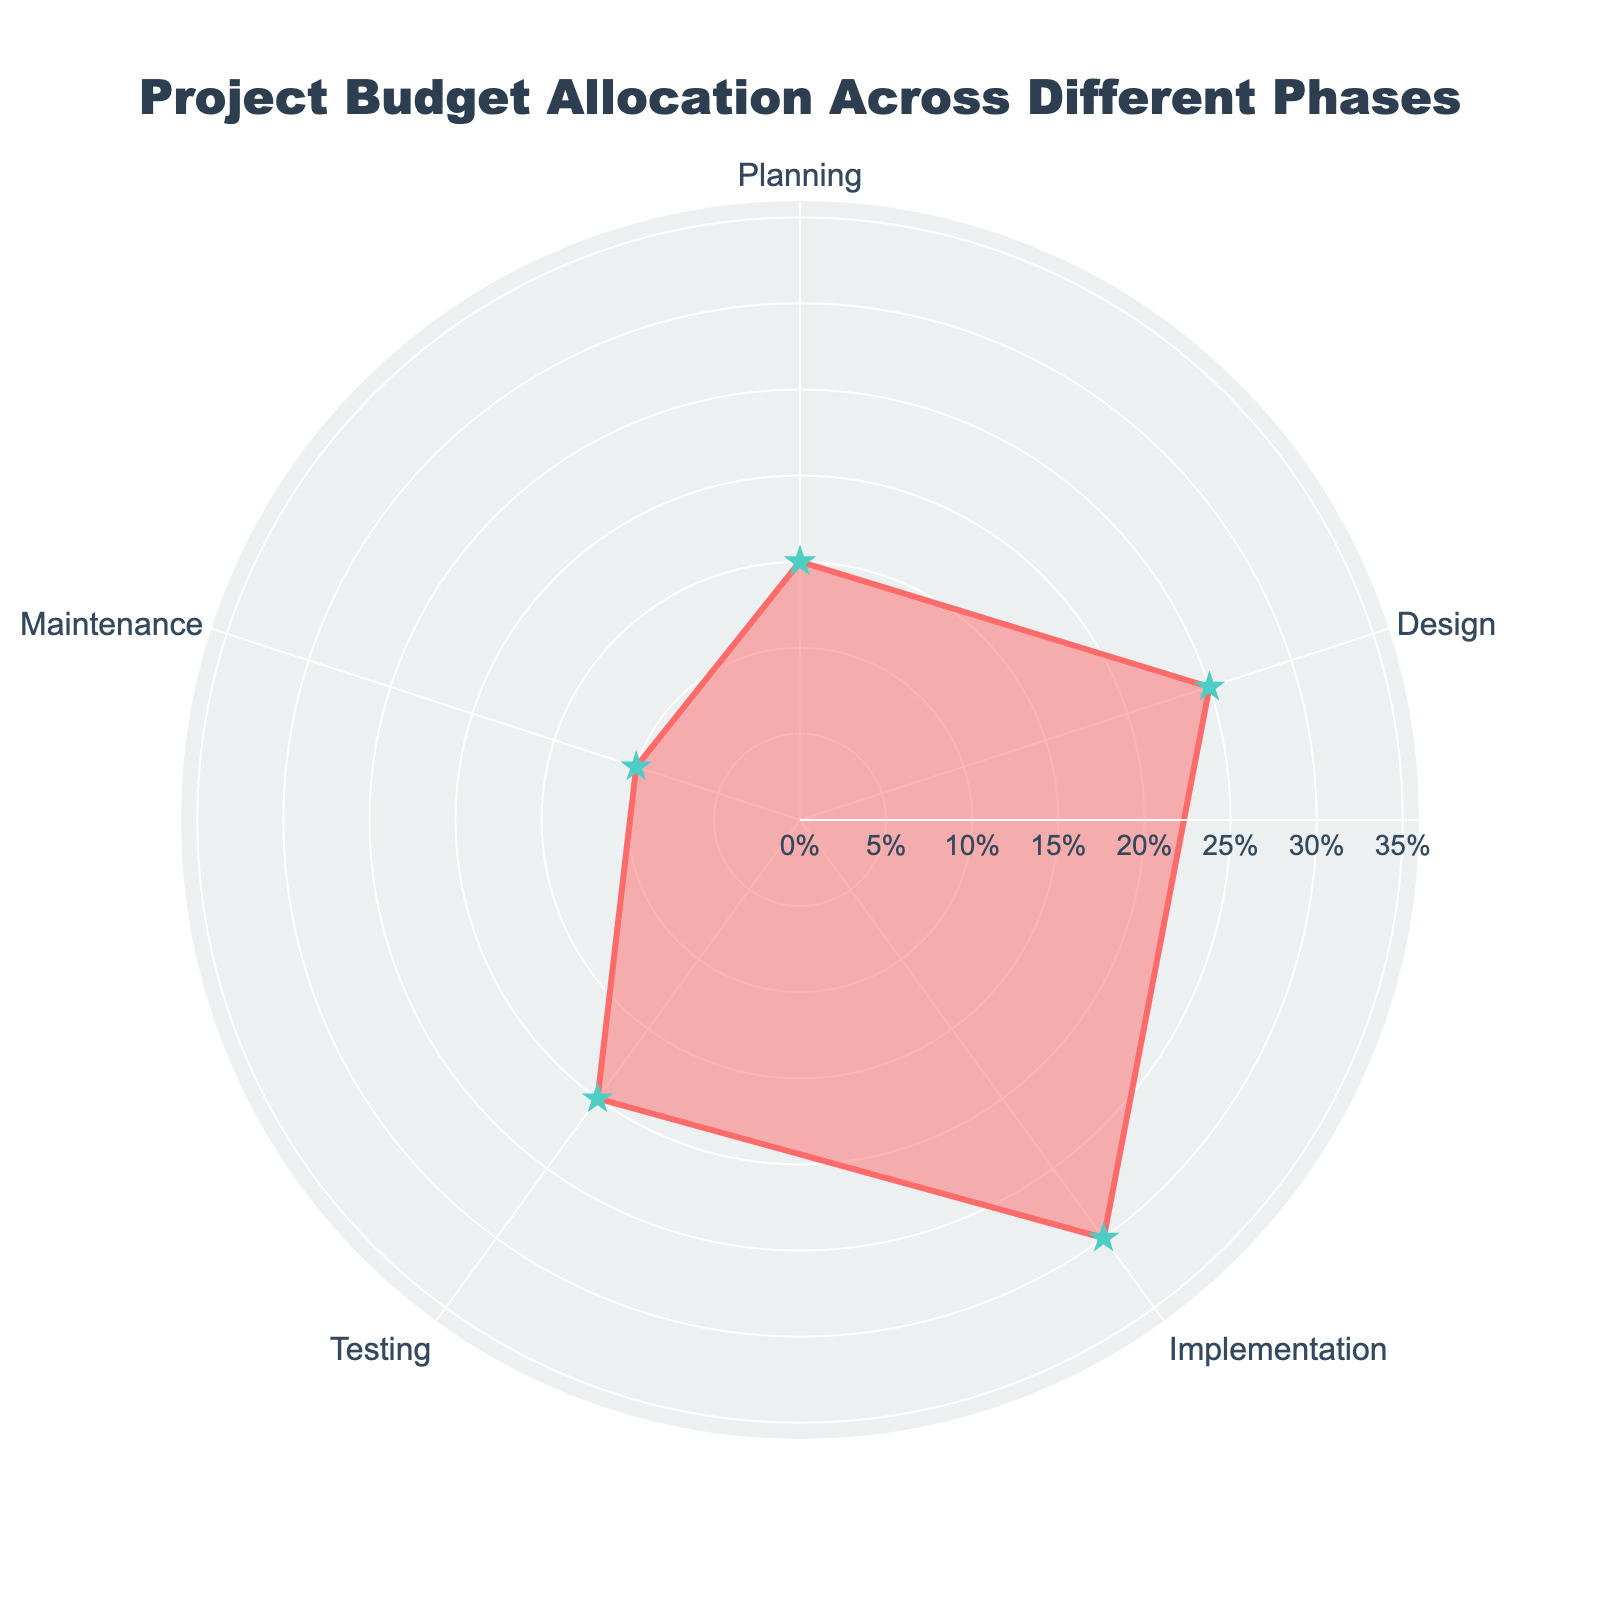what is the title of the chart? The title of the chart is usually positioned prominently at the top, often with a larger font size compared to other text elements. The text is "Project Budget Allocation Across Different Phases".
Answer: Project Budget Allocation Across Different Phases which phase has the largest budget allocation? To determine the phase with the largest budget allocation, look for the point on the outer edge of the plot that is farthest from the center. The phase with the highest percentage is "Implementation" with 30%.
Answer: Implementation What’s the sum of the percentages allocated to Planning and Maintenance? Add the percentages allocated to Planning (15%) and Maintenance (10%) to find the total budget allocation for these two phases. The sum is 15 + 10 = 25%.
Answer: 25% Which phase has the smallest budget allocation? To find the phase with the smallest budget allocation, identify the phase with the point closest to the center of the plot. The minimum percentage is 10% for "Maintenance".
Answer: Maintenance How much larger is the budget percentage of Implementation compared to Testing? Subtract the percentage allocated to Testing (20%) from the percentage allocated to Implementation (30%) to find the difference. The difference is 30 - 20 = 10%.
Answer: 10% What is the range of the budget allocations across different phases? The range is the difference between the largest and smallest budget percentages. The largest is Implementation with 30%, and the smallest is Maintenance with 10%. Range is 30 - 10 = 20%.
Answer: 20% What is the average budget allocation across all phases? To calculate the average, sum all percentages (15 + 25 + 30 + 20 + 10 = 100) and divide by the number of phases (5). The average is 100 / 5 = 20%.
Answer: 20% Which phases allocate more than 20% of the budget? Compare each phase's budget percentage to see if it exceeds 20%. Design and Implementation have allocations greater than 20%, with 25% and 30% respectively.
Answer: Design, Implementation What is the combined budget allocation for Design and Implementation phases? Add the budget percentages of Design (25%) and Implementation (30%) to find the total budget allocated to these two phases. The combined allocation is 25 + 30 = 55%.
Answer: 55% How does the budget allocation for Planning compare to that for Testing? Compare the percentages allocated to Planning (15%) and Testing (20%). Testing has a higher percentage.
Answer: Testing is higher 